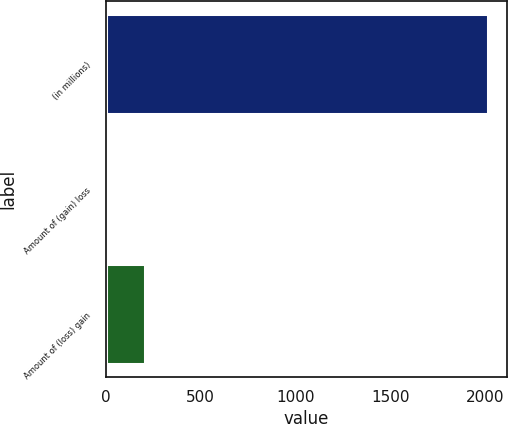Convert chart to OTSL. <chart><loc_0><loc_0><loc_500><loc_500><bar_chart><fcel>(in millions)<fcel>Amount of (gain) loss<fcel>Amount of (loss) gain<nl><fcel>2017<fcel>6<fcel>207.1<nl></chart> 